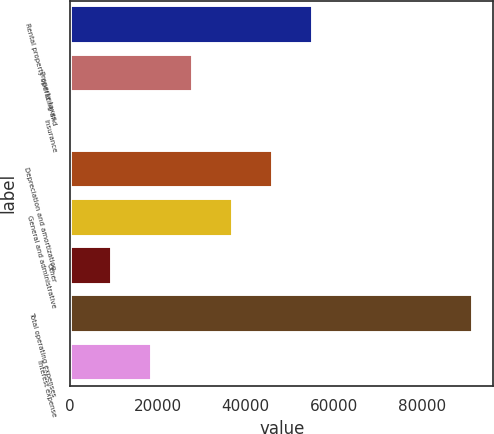Convert chart. <chart><loc_0><loc_0><loc_500><loc_500><bar_chart><fcel>Rental property operating and<fcel>Property taxes<fcel>Insurance<fcel>Depreciation and amortization<fcel>General and administrative<fcel>Other<fcel>Total operating expenses<fcel>Interest expense<nl><fcel>55261.4<fcel>27900.2<fcel>539<fcel>46141<fcel>37020.6<fcel>9659.4<fcel>91743<fcel>18779.8<nl></chart> 